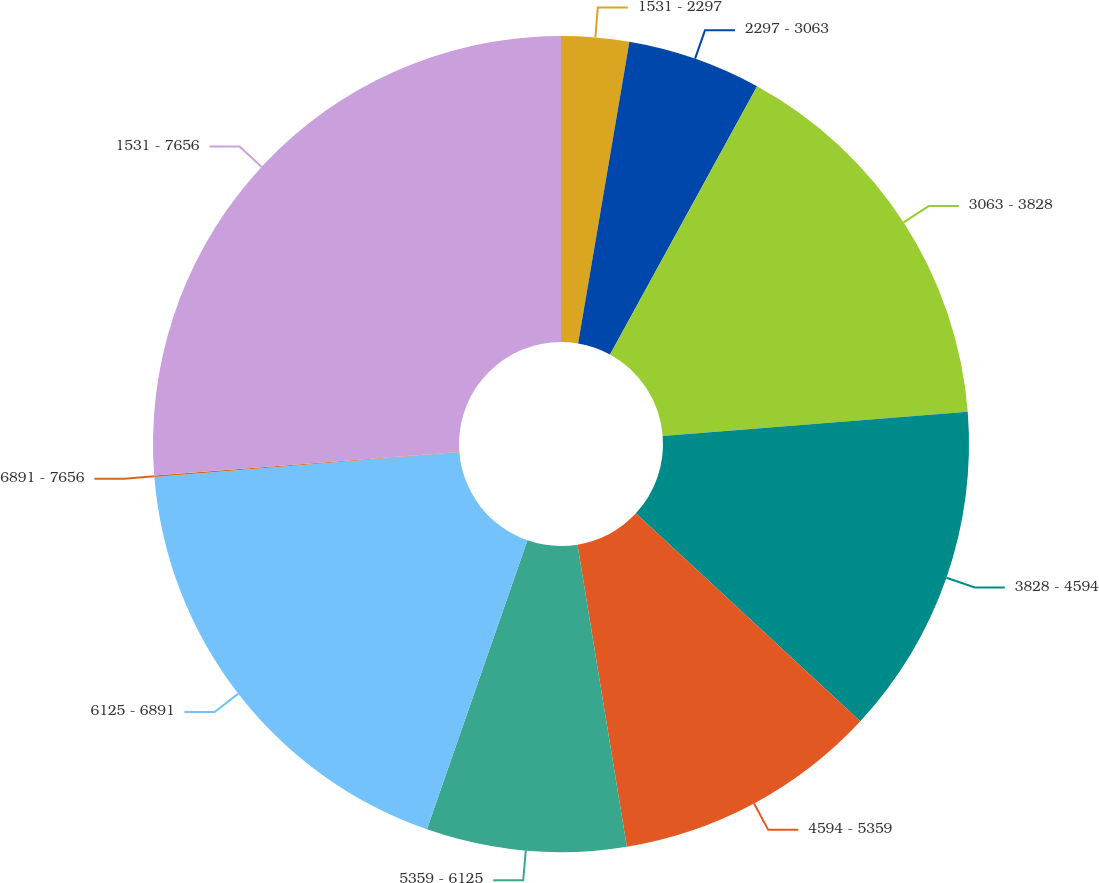Convert chart. <chart><loc_0><loc_0><loc_500><loc_500><pie_chart><fcel>1531 - 2297<fcel>2297 - 3063<fcel>3063 - 3828<fcel>3828 - 4594<fcel>4594 - 5359<fcel>5359 - 6125<fcel>6125 - 6891<fcel>6891 - 7656<fcel>1531 - 7656<nl><fcel>2.68%<fcel>5.3%<fcel>15.76%<fcel>13.15%<fcel>10.53%<fcel>7.91%<fcel>18.38%<fcel>0.06%<fcel>26.23%<nl></chart> 